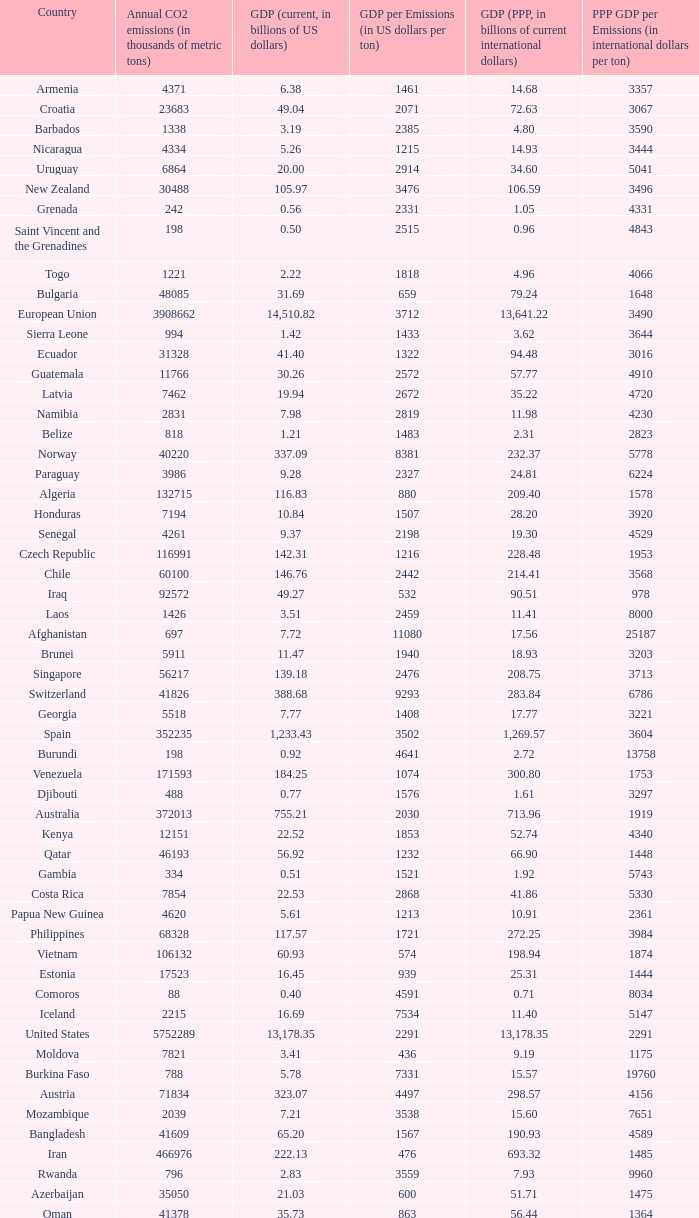When the gdp (ppp, in billions of current international dollars) is 7.93, what is the maximum ppp gdp per emissions (in international dollars per ton)? 9960.0. 